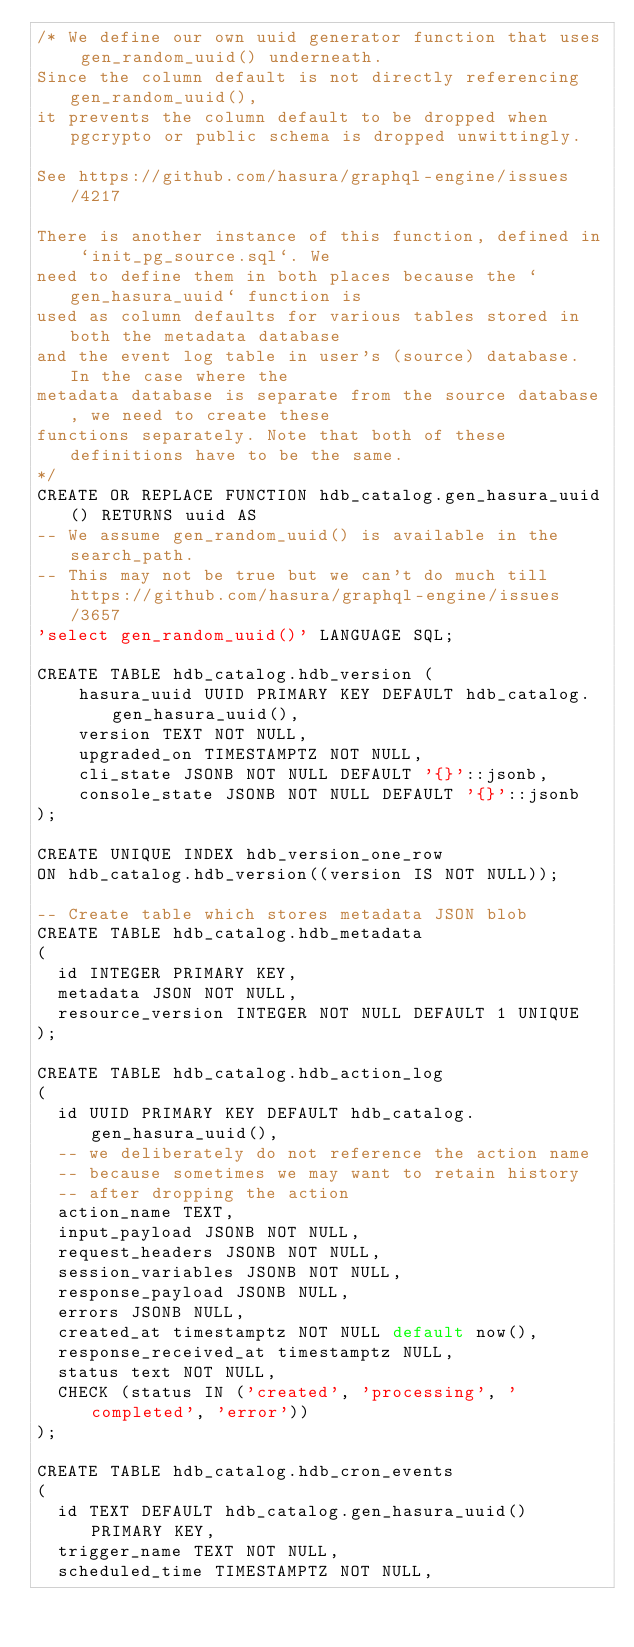Convert code to text. <code><loc_0><loc_0><loc_500><loc_500><_SQL_>/* We define our own uuid generator function that uses gen_random_uuid() underneath.
Since the column default is not directly referencing gen_random_uuid(),
it prevents the column default to be dropped when pgcrypto or public schema is dropped unwittingly.

See https://github.com/hasura/graphql-engine/issues/4217

There is another instance of this function, defined in `init_pg_source.sql`. We
need to define them in both places because the `gen_hasura_uuid` function is
used as column defaults for various tables stored in both the metadata database
and the event log table in user's (source) database. In the case where the
metadata database is separate from the source database, we need to create these
functions separately. Note that both of these definitions have to be the same.
*/
CREATE OR REPLACE FUNCTION hdb_catalog.gen_hasura_uuid() RETURNS uuid AS
-- We assume gen_random_uuid() is available in the search_path.
-- This may not be true but we can't do much till https://github.com/hasura/graphql-engine/issues/3657
'select gen_random_uuid()' LANGUAGE SQL;

CREATE TABLE hdb_catalog.hdb_version (
    hasura_uuid UUID PRIMARY KEY DEFAULT hdb_catalog.gen_hasura_uuid(),
    version TEXT NOT NULL,
    upgraded_on TIMESTAMPTZ NOT NULL,
    cli_state JSONB NOT NULL DEFAULT '{}'::jsonb,
    console_state JSONB NOT NULL DEFAULT '{}'::jsonb
);

CREATE UNIQUE INDEX hdb_version_one_row
ON hdb_catalog.hdb_version((version IS NOT NULL));

-- Create table which stores metadata JSON blob
CREATE TABLE hdb_catalog.hdb_metadata
(
  id INTEGER PRIMARY KEY,
  metadata JSON NOT NULL,
  resource_version INTEGER NOT NULL DEFAULT 1 UNIQUE
);

CREATE TABLE hdb_catalog.hdb_action_log
(
  id UUID PRIMARY KEY DEFAULT hdb_catalog.gen_hasura_uuid(),
  -- we deliberately do not reference the action name
  -- because sometimes we may want to retain history
  -- after dropping the action
  action_name TEXT,
  input_payload JSONB NOT NULL,
  request_headers JSONB NOT NULL,
  session_variables JSONB NOT NULL,
  response_payload JSONB NULL,
  errors JSONB NULL,
  created_at timestamptz NOT NULL default now(),
  response_received_at timestamptz NULL,
  status text NOT NULL,
  CHECK (status IN ('created', 'processing', 'completed', 'error'))
);

CREATE TABLE hdb_catalog.hdb_cron_events
(
  id TEXT DEFAULT hdb_catalog.gen_hasura_uuid() PRIMARY KEY,
  trigger_name TEXT NOT NULL,
  scheduled_time TIMESTAMPTZ NOT NULL,</code> 